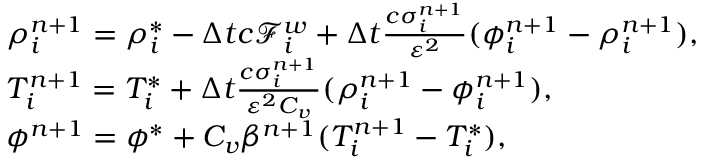Convert formula to latex. <formula><loc_0><loc_0><loc_500><loc_500>\begin{array} { r l } & { \rho _ { i } ^ { n + 1 } = \rho _ { i } ^ { * } - \Delta t c \mathcal { F } _ { i } ^ { w } + \Delta t \frac { c \sigma _ { i } ^ { n + 1 } } { \varepsilon ^ { 2 } } ( \phi _ { i } ^ { n + 1 } - \rho _ { i } ^ { n + 1 } ) , } \\ & { T _ { i } ^ { n + 1 } = T _ { i } ^ { * } + \Delta t \frac { c \sigma _ { i } ^ { n + 1 } } { \varepsilon ^ { 2 } C _ { v } } ( \rho _ { i } ^ { n + 1 } - \phi _ { i } ^ { n + 1 } ) , } \\ & { \phi ^ { n + 1 } = \phi ^ { * } + C _ { v } \beta ^ { n + 1 } ( T _ { i } ^ { n + 1 } - T _ { i } ^ { * } ) , } \end{array}</formula> 